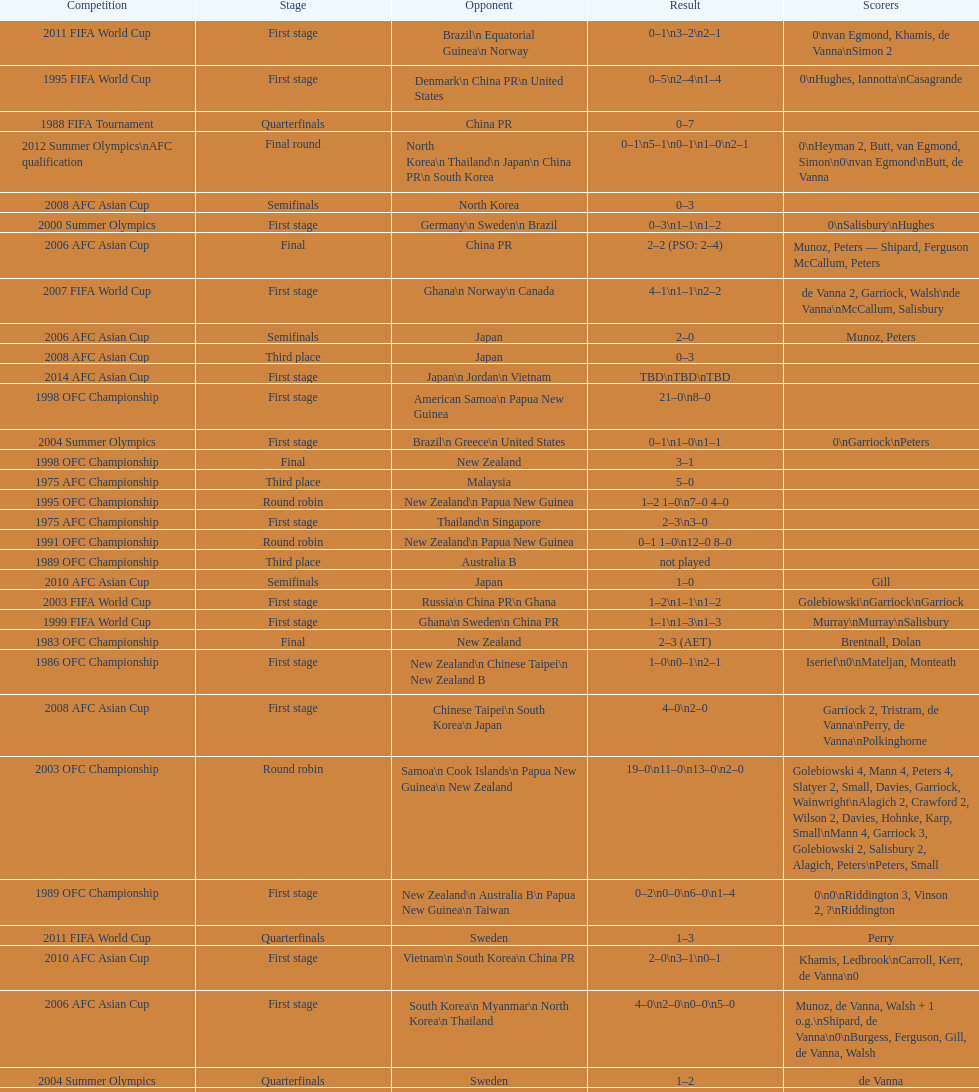How many points were accumulated in the last stage of the 2012 summer olympics afc qualification? 12. 